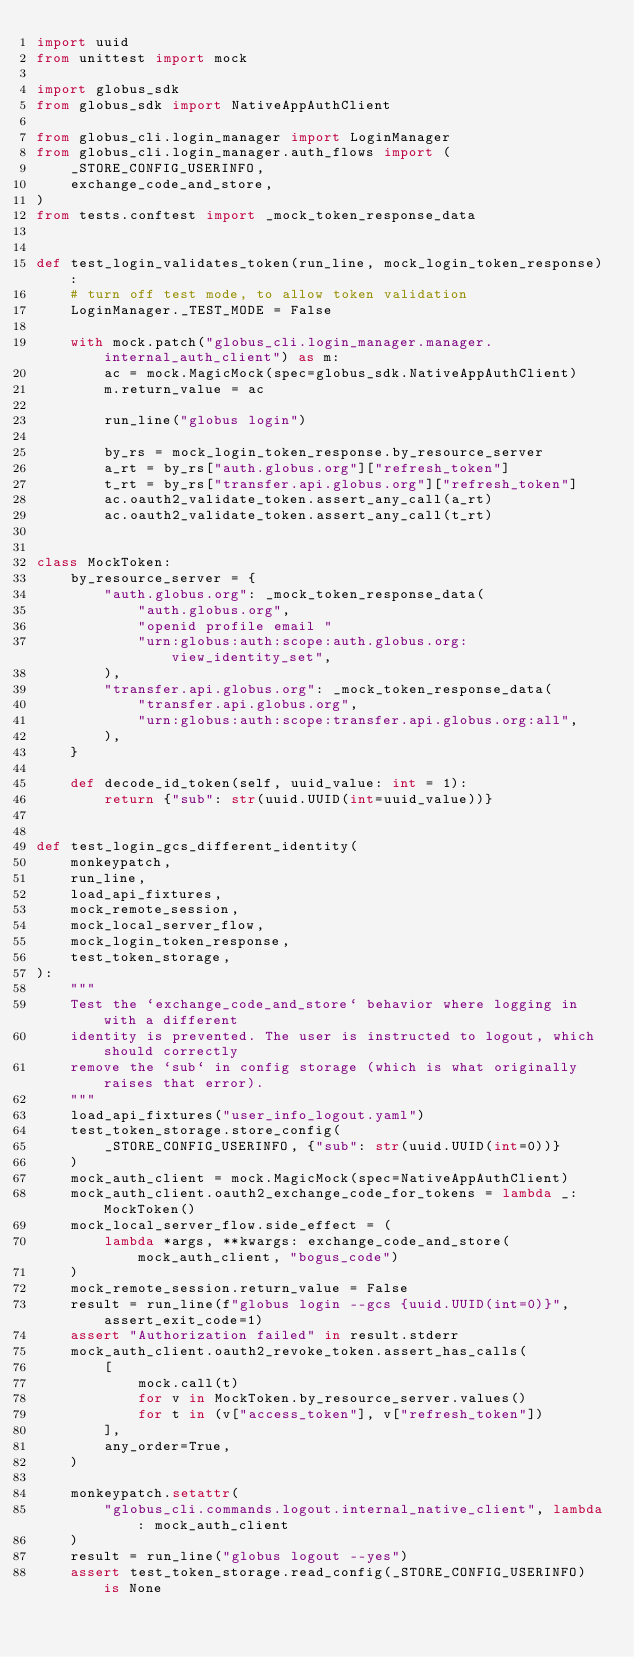Convert code to text. <code><loc_0><loc_0><loc_500><loc_500><_Python_>import uuid
from unittest import mock

import globus_sdk
from globus_sdk import NativeAppAuthClient

from globus_cli.login_manager import LoginManager
from globus_cli.login_manager.auth_flows import (
    _STORE_CONFIG_USERINFO,
    exchange_code_and_store,
)
from tests.conftest import _mock_token_response_data


def test_login_validates_token(run_line, mock_login_token_response):
    # turn off test mode, to allow token validation
    LoginManager._TEST_MODE = False

    with mock.patch("globus_cli.login_manager.manager.internal_auth_client") as m:
        ac = mock.MagicMock(spec=globus_sdk.NativeAppAuthClient)
        m.return_value = ac

        run_line("globus login")

        by_rs = mock_login_token_response.by_resource_server
        a_rt = by_rs["auth.globus.org"]["refresh_token"]
        t_rt = by_rs["transfer.api.globus.org"]["refresh_token"]
        ac.oauth2_validate_token.assert_any_call(a_rt)
        ac.oauth2_validate_token.assert_any_call(t_rt)


class MockToken:
    by_resource_server = {
        "auth.globus.org": _mock_token_response_data(
            "auth.globus.org",
            "openid profile email "
            "urn:globus:auth:scope:auth.globus.org:view_identity_set",
        ),
        "transfer.api.globus.org": _mock_token_response_data(
            "transfer.api.globus.org",
            "urn:globus:auth:scope:transfer.api.globus.org:all",
        ),
    }

    def decode_id_token(self, uuid_value: int = 1):
        return {"sub": str(uuid.UUID(int=uuid_value))}


def test_login_gcs_different_identity(
    monkeypatch,
    run_line,
    load_api_fixtures,
    mock_remote_session,
    mock_local_server_flow,
    mock_login_token_response,
    test_token_storage,
):
    """
    Test the `exchange_code_and_store` behavior where logging in with a different
    identity is prevented. The user is instructed to logout, which should correctly
    remove the `sub` in config storage (which is what originally raises that error).
    """
    load_api_fixtures("user_info_logout.yaml")
    test_token_storage.store_config(
        _STORE_CONFIG_USERINFO, {"sub": str(uuid.UUID(int=0))}
    )
    mock_auth_client = mock.MagicMock(spec=NativeAppAuthClient)
    mock_auth_client.oauth2_exchange_code_for_tokens = lambda _: MockToken()
    mock_local_server_flow.side_effect = (
        lambda *args, **kwargs: exchange_code_and_store(mock_auth_client, "bogus_code")
    )
    mock_remote_session.return_value = False
    result = run_line(f"globus login --gcs {uuid.UUID(int=0)}", assert_exit_code=1)
    assert "Authorization failed" in result.stderr
    mock_auth_client.oauth2_revoke_token.assert_has_calls(
        [
            mock.call(t)
            for v in MockToken.by_resource_server.values()
            for t in (v["access_token"], v["refresh_token"])
        ],
        any_order=True,
    )

    monkeypatch.setattr(
        "globus_cli.commands.logout.internal_native_client", lambda: mock_auth_client
    )
    result = run_line("globus logout --yes")
    assert test_token_storage.read_config(_STORE_CONFIG_USERINFO) is None
</code> 